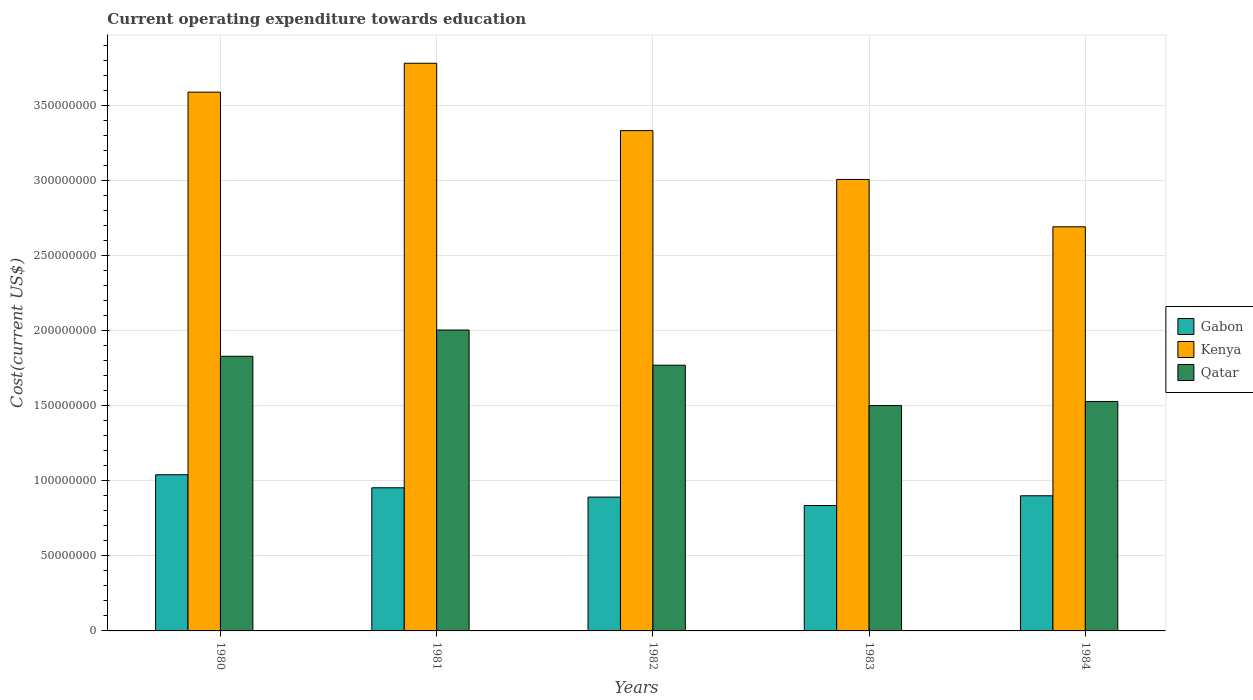How many different coloured bars are there?
Make the answer very short. 3. Are the number of bars per tick equal to the number of legend labels?
Your response must be concise. Yes. How many bars are there on the 5th tick from the left?
Provide a short and direct response. 3. How many bars are there on the 5th tick from the right?
Make the answer very short. 3. What is the label of the 5th group of bars from the left?
Your answer should be very brief. 1984. What is the expenditure towards education in Qatar in 1980?
Your answer should be compact. 1.83e+08. Across all years, what is the maximum expenditure towards education in Gabon?
Provide a succinct answer. 1.04e+08. Across all years, what is the minimum expenditure towards education in Qatar?
Your response must be concise. 1.50e+08. In which year was the expenditure towards education in Qatar maximum?
Offer a terse response. 1981. What is the total expenditure towards education in Qatar in the graph?
Give a very brief answer. 8.64e+08. What is the difference between the expenditure towards education in Qatar in 1980 and that in 1981?
Your answer should be compact. -1.75e+07. What is the difference between the expenditure towards education in Qatar in 1981 and the expenditure towards education in Gabon in 1984?
Make the answer very short. 1.11e+08. What is the average expenditure towards education in Qatar per year?
Make the answer very short. 1.73e+08. In the year 1983, what is the difference between the expenditure towards education in Qatar and expenditure towards education in Kenya?
Your answer should be very brief. -1.51e+08. What is the ratio of the expenditure towards education in Gabon in 1980 to that in 1982?
Give a very brief answer. 1.17. What is the difference between the highest and the second highest expenditure towards education in Gabon?
Offer a very short reply. 8.68e+06. What is the difference between the highest and the lowest expenditure towards education in Kenya?
Ensure brevity in your answer.  1.09e+08. What does the 2nd bar from the left in 1984 represents?
Your answer should be compact. Kenya. What does the 1st bar from the right in 1980 represents?
Your answer should be very brief. Qatar. Is it the case that in every year, the sum of the expenditure towards education in Gabon and expenditure towards education in Qatar is greater than the expenditure towards education in Kenya?
Provide a succinct answer. No. Are all the bars in the graph horizontal?
Your answer should be compact. No. How many years are there in the graph?
Offer a very short reply. 5. What is the difference between two consecutive major ticks on the Y-axis?
Make the answer very short. 5.00e+07. How many legend labels are there?
Your answer should be compact. 3. How are the legend labels stacked?
Ensure brevity in your answer.  Vertical. What is the title of the graph?
Your response must be concise. Current operating expenditure towards education. Does "Hong Kong" appear as one of the legend labels in the graph?
Give a very brief answer. No. What is the label or title of the X-axis?
Provide a short and direct response. Years. What is the label or title of the Y-axis?
Your answer should be compact. Cost(current US$). What is the Cost(current US$) in Gabon in 1980?
Offer a very short reply. 1.04e+08. What is the Cost(current US$) in Kenya in 1980?
Ensure brevity in your answer.  3.59e+08. What is the Cost(current US$) in Qatar in 1980?
Provide a succinct answer. 1.83e+08. What is the Cost(current US$) in Gabon in 1981?
Make the answer very short. 9.54e+07. What is the Cost(current US$) in Kenya in 1981?
Give a very brief answer. 3.78e+08. What is the Cost(current US$) in Qatar in 1981?
Provide a succinct answer. 2.01e+08. What is the Cost(current US$) of Gabon in 1982?
Give a very brief answer. 8.92e+07. What is the Cost(current US$) of Kenya in 1982?
Give a very brief answer. 3.34e+08. What is the Cost(current US$) of Qatar in 1982?
Your response must be concise. 1.77e+08. What is the Cost(current US$) in Gabon in 1983?
Your response must be concise. 8.36e+07. What is the Cost(current US$) in Kenya in 1983?
Ensure brevity in your answer.  3.01e+08. What is the Cost(current US$) in Qatar in 1983?
Give a very brief answer. 1.50e+08. What is the Cost(current US$) of Gabon in 1984?
Ensure brevity in your answer.  9.01e+07. What is the Cost(current US$) in Kenya in 1984?
Your answer should be very brief. 2.69e+08. What is the Cost(current US$) in Qatar in 1984?
Give a very brief answer. 1.53e+08. Across all years, what is the maximum Cost(current US$) of Gabon?
Give a very brief answer. 1.04e+08. Across all years, what is the maximum Cost(current US$) in Kenya?
Provide a succinct answer. 3.78e+08. Across all years, what is the maximum Cost(current US$) in Qatar?
Offer a terse response. 2.01e+08. Across all years, what is the minimum Cost(current US$) of Gabon?
Your answer should be very brief. 8.36e+07. Across all years, what is the minimum Cost(current US$) in Kenya?
Keep it short and to the point. 2.69e+08. Across all years, what is the minimum Cost(current US$) of Qatar?
Your answer should be very brief. 1.50e+08. What is the total Cost(current US$) of Gabon in the graph?
Your answer should be compact. 4.62e+08. What is the total Cost(current US$) of Kenya in the graph?
Offer a terse response. 1.64e+09. What is the total Cost(current US$) of Qatar in the graph?
Ensure brevity in your answer.  8.64e+08. What is the difference between the Cost(current US$) of Gabon in 1980 and that in 1981?
Your answer should be compact. 8.68e+06. What is the difference between the Cost(current US$) of Kenya in 1980 and that in 1981?
Your response must be concise. -1.93e+07. What is the difference between the Cost(current US$) in Qatar in 1980 and that in 1981?
Keep it short and to the point. -1.75e+07. What is the difference between the Cost(current US$) of Gabon in 1980 and that in 1982?
Give a very brief answer. 1.49e+07. What is the difference between the Cost(current US$) in Kenya in 1980 and that in 1982?
Make the answer very short. 2.56e+07. What is the difference between the Cost(current US$) of Qatar in 1980 and that in 1982?
Offer a terse response. 5.94e+06. What is the difference between the Cost(current US$) in Gabon in 1980 and that in 1983?
Your response must be concise. 2.05e+07. What is the difference between the Cost(current US$) of Kenya in 1980 and that in 1983?
Provide a succinct answer. 5.82e+07. What is the difference between the Cost(current US$) of Qatar in 1980 and that in 1983?
Keep it short and to the point. 3.29e+07. What is the difference between the Cost(current US$) of Gabon in 1980 and that in 1984?
Give a very brief answer. 1.40e+07. What is the difference between the Cost(current US$) in Kenya in 1980 and that in 1984?
Your answer should be very brief. 8.98e+07. What is the difference between the Cost(current US$) in Qatar in 1980 and that in 1984?
Provide a short and direct response. 3.01e+07. What is the difference between the Cost(current US$) of Gabon in 1981 and that in 1982?
Ensure brevity in your answer.  6.20e+06. What is the difference between the Cost(current US$) of Kenya in 1981 and that in 1982?
Provide a short and direct response. 4.49e+07. What is the difference between the Cost(current US$) in Qatar in 1981 and that in 1982?
Your answer should be very brief. 2.34e+07. What is the difference between the Cost(current US$) in Gabon in 1981 and that in 1983?
Give a very brief answer. 1.18e+07. What is the difference between the Cost(current US$) in Kenya in 1981 and that in 1983?
Offer a terse response. 7.75e+07. What is the difference between the Cost(current US$) of Qatar in 1981 and that in 1983?
Offer a very short reply. 5.04e+07. What is the difference between the Cost(current US$) in Gabon in 1981 and that in 1984?
Make the answer very short. 5.32e+06. What is the difference between the Cost(current US$) of Kenya in 1981 and that in 1984?
Offer a terse response. 1.09e+08. What is the difference between the Cost(current US$) in Qatar in 1981 and that in 1984?
Your answer should be compact. 4.76e+07. What is the difference between the Cost(current US$) in Gabon in 1982 and that in 1983?
Make the answer very short. 5.63e+06. What is the difference between the Cost(current US$) of Kenya in 1982 and that in 1983?
Offer a terse response. 3.26e+07. What is the difference between the Cost(current US$) of Qatar in 1982 and that in 1983?
Provide a short and direct response. 2.69e+07. What is the difference between the Cost(current US$) in Gabon in 1982 and that in 1984?
Give a very brief answer. -8.78e+05. What is the difference between the Cost(current US$) in Kenya in 1982 and that in 1984?
Your answer should be compact. 6.41e+07. What is the difference between the Cost(current US$) in Qatar in 1982 and that in 1984?
Your answer should be compact. 2.42e+07. What is the difference between the Cost(current US$) in Gabon in 1983 and that in 1984?
Provide a succinct answer. -6.51e+06. What is the difference between the Cost(current US$) in Kenya in 1983 and that in 1984?
Offer a very short reply. 3.16e+07. What is the difference between the Cost(current US$) in Qatar in 1983 and that in 1984?
Keep it short and to the point. -2.74e+06. What is the difference between the Cost(current US$) of Gabon in 1980 and the Cost(current US$) of Kenya in 1981?
Keep it short and to the point. -2.74e+08. What is the difference between the Cost(current US$) in Gabon in 1980 and the Cost(current US$) in Qatar in 1981?
Your answer should be compact. -9.65e+07. What is the difference between the Cost(current US$) of Kenya in 1980 and the Cost(current US$) of Qatar in 1981?
Provide a short and direct response. 1.59e+08. What is the difference between the Cost(current US$) in Gabon in 1980 and the Cost(current US$) in Kenya in 1982?
Make the answer very short. -2.29e+08. What is the difference between the Cost(current US$) of Gabon in 1980 and the Cost(current US$) of Qatar in 1982?
Offer a terse response. -7.31e+07. What is the difference between the Cost(current US$) in Kenya in 1980 and the Cost(current US$) in Qatar in 1982?
Offer a very short reply. 1.82e+08. What is the difference between the Cost(current US$) in Gabon in 1980 and the Cost(current US$) in Kenya in 1983?
Offer a terse response. -1.97e+08. What is the difference between the Cost(current US$) of Gabon in 1980 and the Cost(current US$) of Qatar in 1983?
Make the answer very short. -4.61e+07. What is the difference between the Cost(current US$) of Kenya in 1980 and the Cost(current US$) of Qatar in 1983?
Keep it short and to the point. 2.09e+08. What is the difference between the Cost(current US$) in Gabon in 1980 and the Cost(current US$) in Kenya in 1984?
Give a very brief answer. -1.65e+08. What is the difference between the Cost(current US$) in Gabon in 1980 and the Cost(current US$) in Qatar in 1984?
Offer a very short reply. -4.89e+07. What is the difference between the Cost(current US$) of Kenya in 1980 and the Cost(current US$) of Qatar in 1984?
Offer a terse response. 2.06e+08. What is the difference between the Cost(current US$) in Gabon in 1981 and the Cost(current US$) in Kenya in 1982?
Your answer should be very brief. -2.38e+08. What is the difference between the Cost(current US$) in Gabon in 1981 and the Cost(current US$) in Qatar in 1982?
Keep it short and to the point. -8.17e+07. What is the difference between the Cost(current US$) of Kenya in 1981 and the Cost(current US$) of Qatar in 1982?
Provide a succinct answer. 2.01e+08. What is the difference between the Cost(current US$) in Gabon in 1981 and the Cost(current US$) in Kenya in 1983?
Offer a terse response. -2.06e+08. What is the difference between the Cost(current US$) in Gabon in 1981 and the Cost(current US$) in Qatar in 1983?
Offer a very short reply. -5.48e+07. What is the difference between the Cost(current US$) of Kenya in 1981 and the Cost(current US$) of Qatar in 1983?
Keep it short and to the point. 2.28e+08. What is the difference between the Cost(current US$) of Gabon in 1981 and the Cost(current US$) of Kenya in 1984?
Your response must be concise. -1.74e+08. What is the difference between the Cost(current US$) of Gabon in 1981 and the Cost(current US$) of Qatar in 1984?
Your answer should be very brief. -5.76e+07. What is the difference between the Cost(current US$) of Kenya in 1981 and the Cost(current US$) of Qatar in 1984?
Keep it short and to the point. 2.25e+08. What is the difference between the Cost(current US$) in Gabon in 1982 and the Cost(current US$) in Kenya in 1983?
Your answer should be compact. -2.12e+08. What is the difference between the Cost(current US$) of Gabon in 1982 and the Cost(current US$) of Qatar in 1983?
Ensure brevity in your answer.  -6.10e+07. What is the difference between the Cost(current US$) of Kenya in 1982 and the Cost(current US$) of Qatar in 1983?
Your answer should be compact. 1.83e+08. What is the difference between the Cost(current US$) of Gabon in 1982 and the Cost(current US$) of Kenya in 1984?
Offer a terse response. -1.80e+08. What is the difference between the Cost(current US$) of Gabon in 1982 and the Cost(current US$) of Qatar in 1984?
Give a very brief answer. -6.38e+07. What is the difference between the Cost(current US$) of Kenya in 1982 and the Cost(current US$) of Qatar in 1984?
Your response must be concise. 1.81e+08. What is the difference between the Cost(current US$) in Gabon in 1983 and the Cost(current US$) in Kenya in 1984?
Make the answer very short. -1.86e+08. What is the difference between the Cost(current US$) of Gabon in 1983 and the Cost(current US$) of Qatar in 1984?
Your answer should be very brief. -6.94e+07. What is the difference between the Cost(current US$) in Kenya in 1983 and the Cost(current US$) in Qatar in 1984?
Offer a very short reply. 1.48e+08. What is the average Cost(current US$) of Gabon per year?
Keep it short and to the point. 9.25e+07. What is the average Cost(current US$) in Kenya per year?
Make the answer very short. 3.28e+08. What is the average Cost(current US$) in Qatar per year?
Your answer should be very brief. 1.73e+08. In the year 1980, what is the difference between the Cost(current US$) in Gabon and Cost(current US$) in Kenya?
Provide a succinct answer. -2.55e+08. In the year 1980, what is the difference between the Cost(current US$) of Gabon and Cost(current US$) of Qatar?
Offer a very short reply. -7.90e+07. In the year 1980, what is the difference between the Cost(current US$) in Kenya and Cost(current US$) in Qatar?
Ensure brevity in your answer.  1.76e+08. In the year 1981, what is the difference between the Cost(current US$) in Gabon and Cost(current US$) in Kenya?
Provide a succinct answer. -2.83e+08. In the year 1981, what is the difference between the Cost(current US$) of Gabon and Cost(current US$) of Qatar?
Give a very brief answer. -1.05e+08. In the year 1981, what is the difference between the Cost(current US$) in Kenya and Cost(current US$) in Qatar?
Offer a very short reply. 1.78e+08. In the year 1982, what is the difference between the Cost(current US$) in Gabon and Cost(current US$) in Kenya?
Give a very brief answer. -2.44e+08. In the year 1982, what is the difference between the Cost(current US$) in Gabon and Cost(current US$) in Qatar?
Ensure brevity in your answer.  -8.79e+07. In the year 1982, what is the difference between the Cost(current US$) in Kenya and Cost(current US$) in Qatar?
Keep it short and to the point. 1.56e+08. In the year 1983, what is the difference between the Cost(current US$) in Gabon and Cost(current US$) in Kenya?
Offer a terse response. -2.17e+08. In the year 1983, what is the difference between the Cost(current US$) of Gabon and Cost(current US$) of Qatar?
Offer a terse response. -6.66e+07. In the year 1983, what is the difference between the Cost(current US$) in Kenya and Cost(current US$) in Qatar?
Your answer should be very brief. 1.51e+08. In the year 1984, what is the difference between the Cost(current US$) of Gabon and Cost(current US$) of Kenya?
Ensure brevity in your answer.  -1.79e+08. In the year 1984, what is the difference between the Cost(current US$) of Gabon and Cost(current US$) of Qatar?
Make the answer very short. -6.29e+07. In the year 1984, what is the difference between the Cost(current US$) of Kenya and Cost(current US$) of Qatar?
Keep it short and to the point. 1.16e+08. What is the ratio of the Cost(current US$) of Gabon in 1980 to that in 1981?
Your response must be concise. 1.09. What is the ratio of the Cost(current US$) of Kenya in 1980 to that in 1981?
Keep it short and to the point. 0.95. What is the ratio of the Cost(current US$) of Qatar in 1980 to that in 1981?
Make the answer very short. 0.91. What is the ratio of the Cost(current US$) of Gabon in 1980 to that in 1982?
Provide a short and direct response. 1.17. What is the ratio of the Cost(current US$) of Kenya in 1980 to that in 1982?
Ensure brevity in your answer.  1.08. What is the ratio of the Cost(current US$) of Qatar in 1980 to that in 1982?
Your answer should be very brief. 1.03. What is the ratio of the Cost(current US$) of Gabon in 1980 to that in 1983?
Provide a succinct answer. 1.25. What is the ratio of the Cost(current US$) in Kenya in 1980 to that in 1983?
Make the answer very short. 1.19. What is the ratio of the Cost(current US$) of Qatar in 1980 to that in 1983?
Offer a terse response. 1.22. What is the ratio of the Cost(current US$) of Gabon in 1980 to that in 1984?
Make the answer very short. 1.16. What is the ratio of the Cost(current US$) of Kenya in 1980 to that in 1984?
Provide a succinct answer. 1.33. What is the ratio of the Cost(current US$) of Qatar in 1980 to that in 1984?
Keep it short and to the point. 1.2. What is the ratio of the Cost(current US$) in Gabon in 1981 to that in 1982?
Provide a succinct answer. 1.07. What is the ratio of the Cost(current US$) of Kenya in 1981 to that in 1982?
Give a very brief answer. 1.13. What is the ratio of the Cost(current US$) of Qatar in 1981 to that in 1982?
Provide a short and direct response. 1.13. What is the ratio of the Cost(current US$) in Gabon in 1981 to that in 1983?
Your answer should be compact. 1.14. What is the ratio of the Cost(current US$) of Kenya in 1981 to that in 1983?
Make the answer very short. 1.26. What is the ratio of the Cost(current US$) in Qatar in 1981 to that in 1983?
Offer a terse response. 1.34. What is the ratio of the Cost(current US$) in Gabon in 1981 to that in 1984?
Give a very brief answer. 1.06. What is the ratio of the Cost(current US$) in Kenya in 1981 to that in 1984?
Make the answer very short. 1.4. What is the ratio of the Cost(current US$) of Qatar in 1981 to that in 1984?
Provide a succinct answer. 1.31. What is the ratio of the Cost(current US$) of Gabon in 1982 to that in 1983?
Make the answer very short. 1.07. What is the ratio of the Cost(current US$) in Kenya in 1982 to that in 1983?
Provide a succinct answer. 1.11. What is the ratio of the Cost(current US$) of Qatar in 1982 to that in 1983?
Give a very brief answer. 1.18. What is the ratio of the Cost(current US$) of Gabon in 1982 to that in 1984?
Offer a very short reply. 0.99. What is the ratio of the Cost(current US$) of Kenya in 1982 to that in 1984?
Offer a terse response. 1.24. What is the ratio of the Cost(current US$) of Qatar in 1982 to that in 1984?
Offer a very short reply. 1.16. What is the ratio of the Cost(current US$) in Gabon in 1983 to that in 1984?
Provide a short and direct response. 0.93. What is the ratio of the Cost(current US$) of Kenya in 1983 to that in 1984?
Offer a terse response. 1.12. What is the ratio of the Cost(current US$) in Qatar in 1983 to that in 1984?
Provide a succinct answer. 0.98. What is the difference between the highest and the second highest Cost(current US$) of Gabon?
Offer a terse response. 8.68e+06. What is the difference between the highest and the second highest Cost(current US$) in Kenya?
Offer a terse response. 1.93e+07. What is the difference between the highest and the second highest Cost(current US$) of Qatar?
Keep it short and to the point. 1.75e+07. What is the difference between the highest and the lowest Cost(current US$) of Gabon?
Ensure brevity in your answer.  2.05e+07. What is the difference between the highest and the lowest Cost(current US$) of Kenya?
Offer a terse response. 1.09e+08. What is the difference between the highest and the lowest Cost(current US$) of Qatar?
Your answer should be very brief. 5.04e+07. 